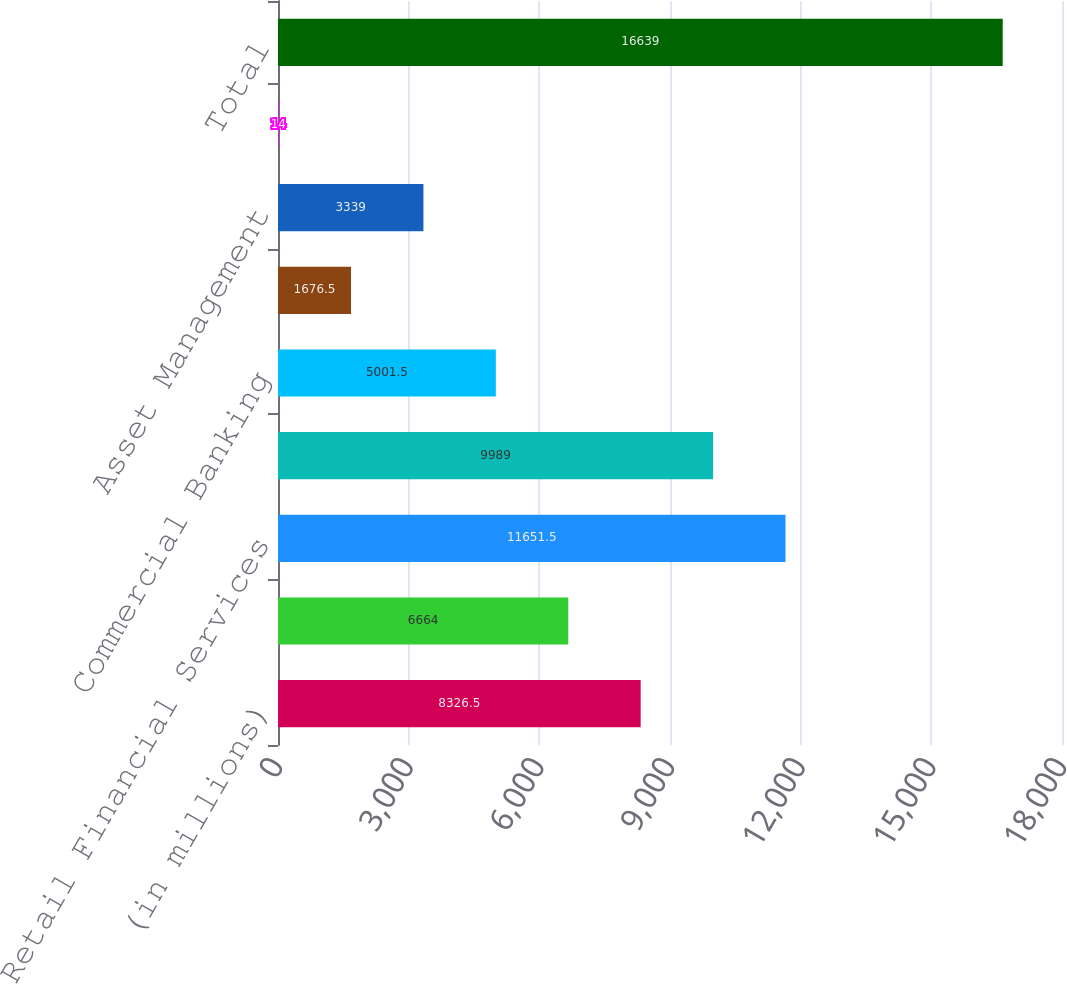<chart> <loc_0><loc_0><loc_500><loc_500><bar_chart><fcel>(in millions)<fcel>Investment Bank (b)<fcel>Retail Financial Services<fcel>Card Services<fcel>Commercial Banking<fcel>Treasury & Securities Services<fcel>Asset Management<fcel>Corporate/Private Equity (b)<fcel>Total<nl><fcel>8326.5<fcel>6664<fcel>11651.5<fcel>9989<fcel>5001.5<fcel>1676.5<fcel>3339<fcel>14<fcel>16639<nl></chart> 